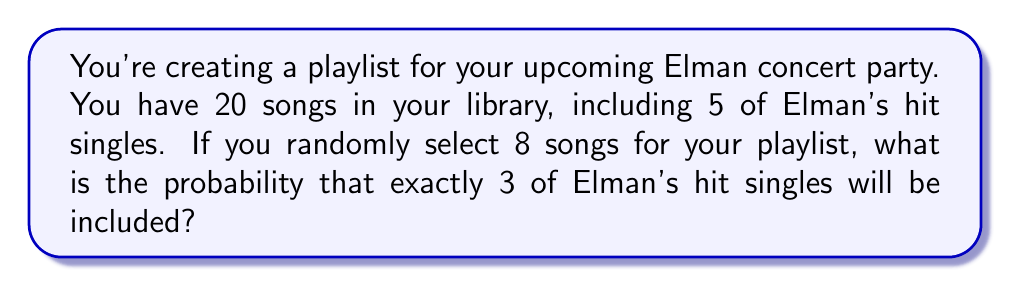Could you help me with this problem? Let's approach this step-by-step using the hypergeometric distribution:

1) We have:
   - Total songs in library: $N = 20$
   - Elman's hit singles: $K = 5$
   - Songs selected for playlist: $n = 8$
   - Desired number of Elman's hits in playlist: $k = 3$

2) The probability is given by the hypergeometric distribution formula:

   $$P(X = k) = \frac{\binom{K}{k} \binom{N-K}{n-k}}{\binom{N}{n}}$$

3) Let's calculate each combination:

   $\binom{5}{3} = \frac{5!}{3!(5-3)!} = 10$

   $\binom{15}{5} = \frac{15!}{5!(15-5)!} = 3003$

   $\binom{20}{8} = \frac{20!}{8!(20-8)!} = 125970$

4) Now, let's substitute these values into our formula:

   $$P(X = 3) = \frac{10 \cdot 3003}{125970}$$

5) Simplifying:

   $$P(X = 3) = \frac{30030}{125970} = \frac{3003}{12597} \approx 0.2384$$
Answer: $\frac{3003}{12597}$ 